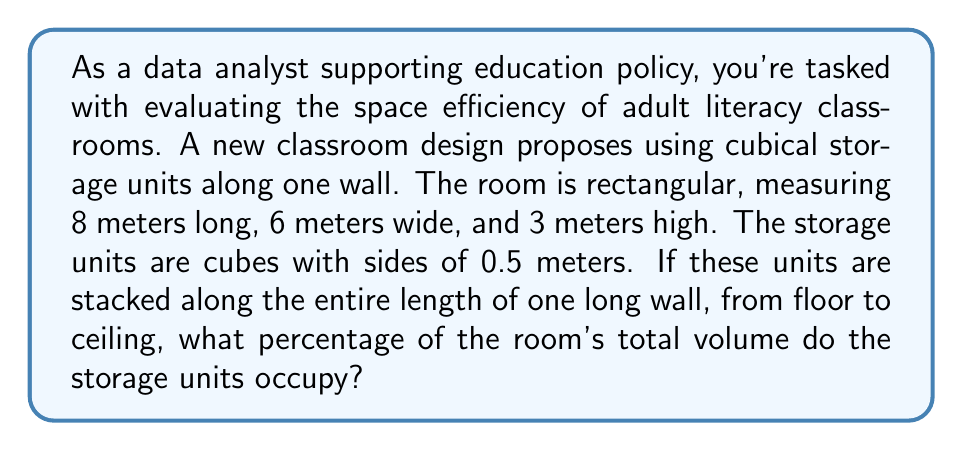Can you answer this question? To solve this problem, we need to follow these steps:

1. Calculate the volume of the classroom:
   $$V_{room} = length \times width \times height$$
   $$V_{room} = 8 \times 6 \times 3 = 144 \text{ m}^3$$

2. Calculate the number of storage units that can fit along the wall:
   - Length: $8 \div 0.5 = 16$ units
   - Height: $3 \div 0.5 = 6$ units
   Total units = $16 \times 6 = 96$ units

3. Calculate the volume of a single storage unit:
   $$V_{unit} = 0.5 \times 0.5 \times 0.5 = 0.125 \text{ m}^3$$

4. Calculate the total volume of all storage units:
   $$V_{total\_units} = 96 \times 0.125 = 12 \text{ m}^3$$

5. Calculate the percentage of room volume occupied by storage units:
   $$\text{Percentage} = \frac{V_{total\_units}}{V_{room}} \times 100\%$$
   $$\text{Percentage} = \frac{12}{144} \times 100\% = 8.33\%$$

This analysis shows that the storage units would occupy 8.33% of the classroom's total volume, leaving 91.67% for learning activities. This information can help education policy analysts assess whether the proposed design efficiently balances storage needs with active learning space in adult literacy programs.
Answer: The storage units occupy 8.33% of the classroom's total volume. 